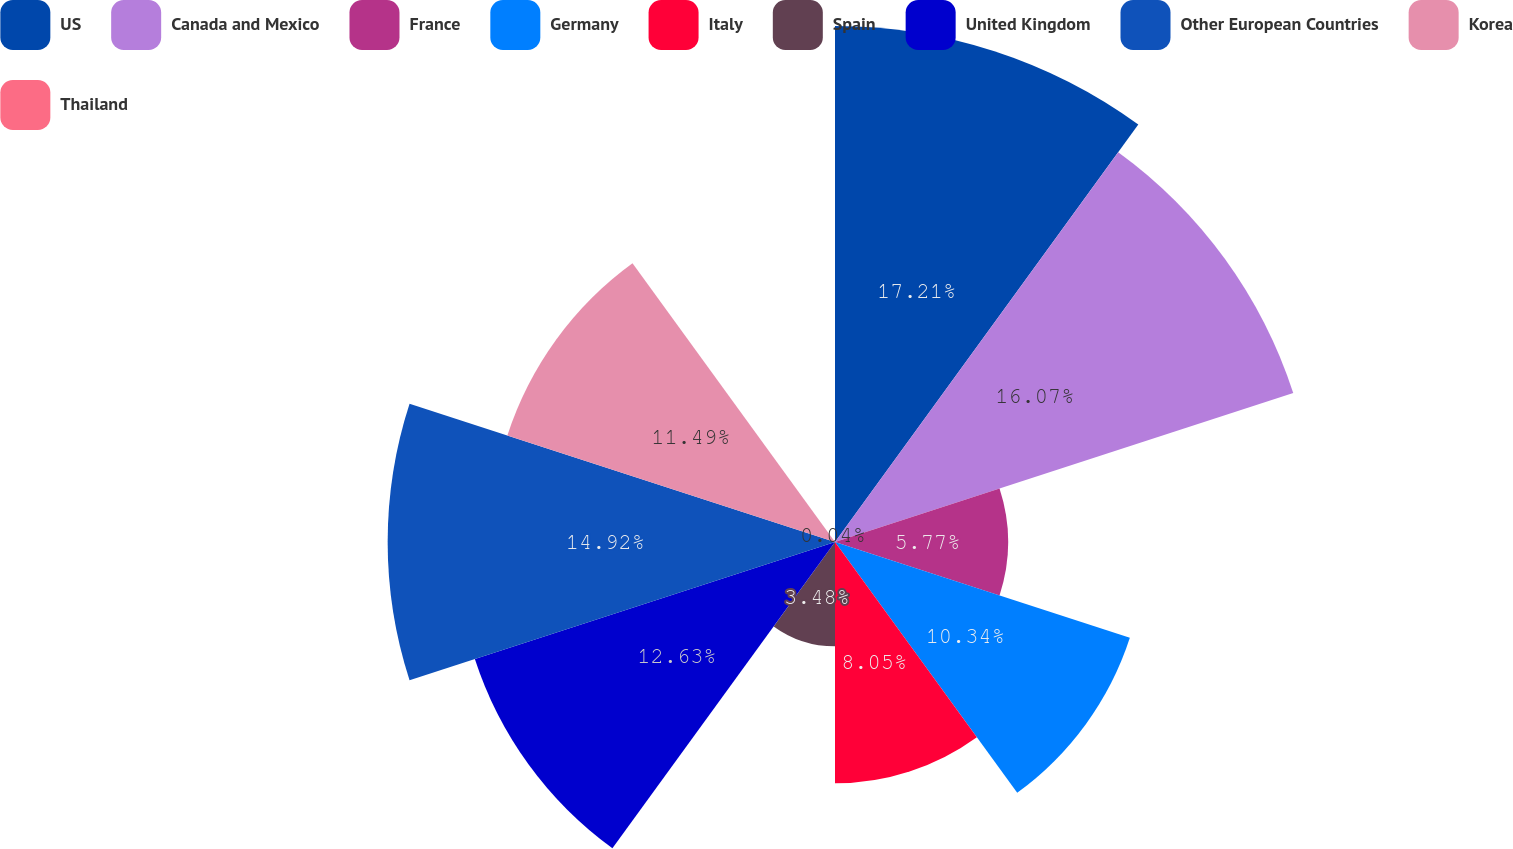Convert chart to OTSL. <chart><loc_0><loc_0><loc_500><loc_500><pie_chart><fcel>US<fcel>Canada and Mexico<fcel>France<fcel>Germany<fcel>Italy<fcel>Spain<fcel>United Kingdom<fcel>Other European Countries<fcel>Korea<fcel>Thailand<nl><fcel>17.21%<fcel>16.07%<fcel>5.77%<fcel>10.34%<fcel>8.05%<fcel>3.48%<fcel>12.63%<fcel>14.92%<fcel>11.49%<fcel>0.04%<nl></chart> 